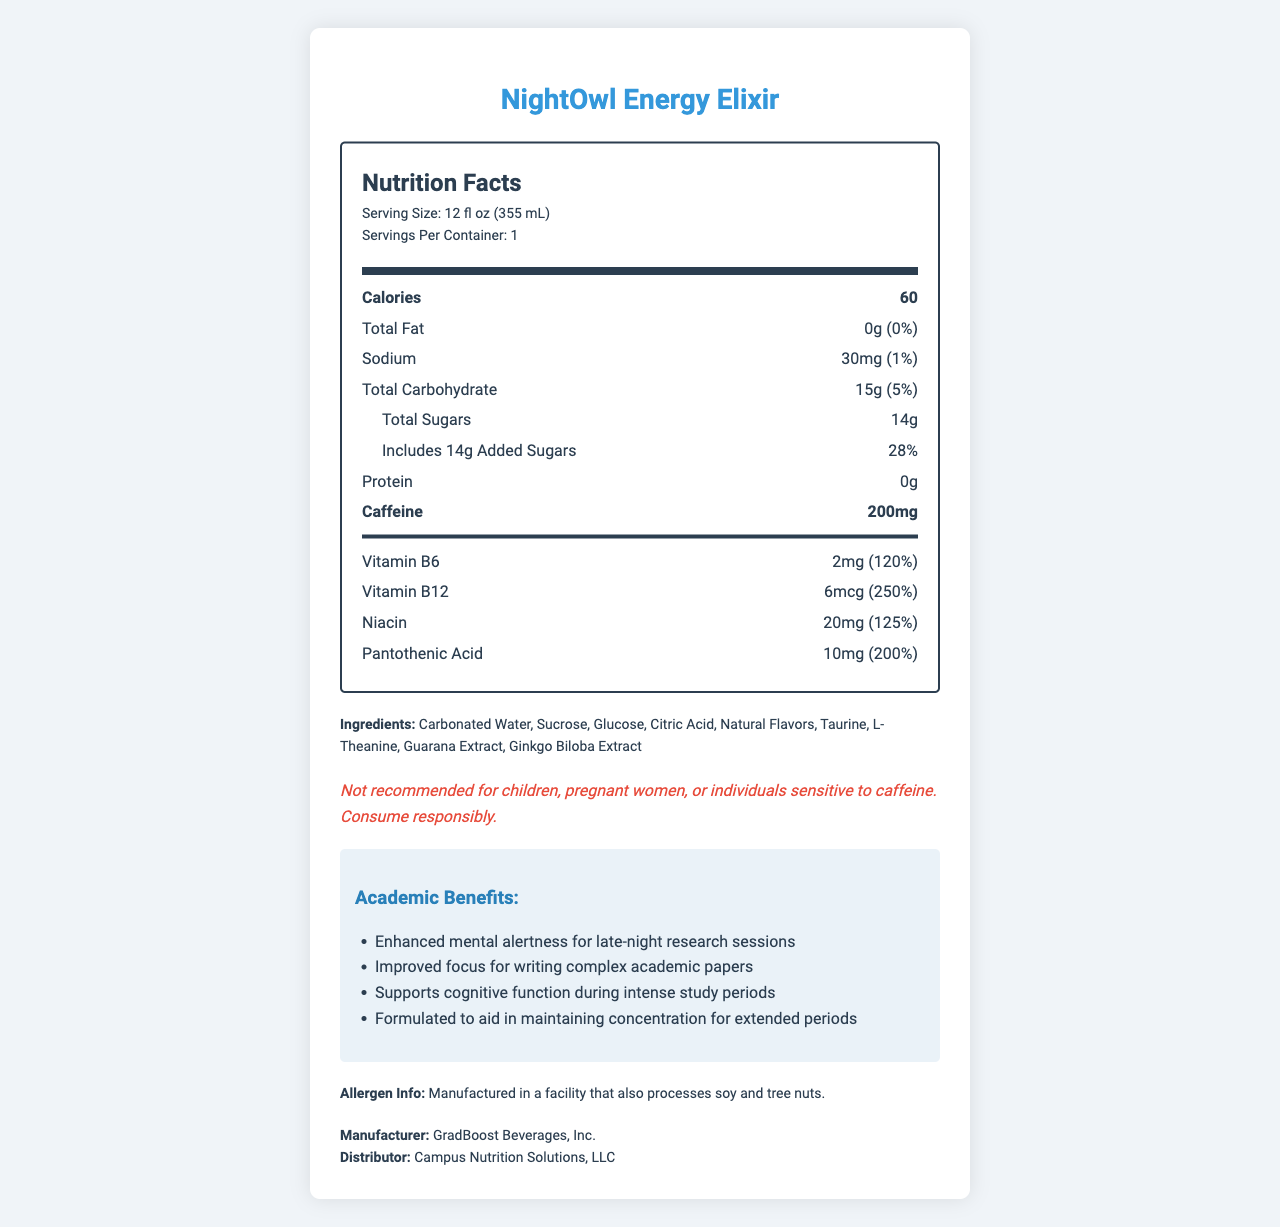what is the serving size of NightOwl Energy Elixir? The serving size is listed at the top under the 'Nutrition Facts' section, specified as 12 fl oz (355 mL).
Answer: 12 fl oz (355 mL) How many calories are there in a single serving of NightOwl Energy Elixir? The number of calories per serving is displayed prominently under the 'Nutrition Facts' section.
Answer: 60 What is the amount of caffeine in NightOwl Energy Elixir? The amount of caffeine is shown under the nutrition items and is highlighted in a bold font.
Answer: 200mg What percentage of the daily value for Vitamin B12 does NightOwl Energy Elixir provide? The daily value percentages for vitamins and minerals are listed, and Vitamin B12 provides 250% of the daily value.
Answer: 250% Name two key academic benefits of consuming NightOwl Energy Elixir. The academic benefits are listed in a bullet-point format, specifying various advantages the beverage offers for academic activities.
Answer: Enhanced mental alertness for late-night research sessions and improved focus for writing complex academic papers Which of the following is an ingredient in NightOwl Energy Elixir? A. Aspartame B. High Fructose Corn Syrup C. Taurine D. Soy Protein The ingredients list includes Taurine but not Aspartame, High Fructose Corn Syrup, or Soy Protein.
Answer: C What is the total carbohydrate content and its daily value percentage? Under the 'Nutrition Facts' section, the total carbohydrate content is listed as 15g with a 5% daily value.
Answer: 15g (5%) Is NightOwl Energy Elixir recommended for children? Yes or No The disclaimer explicitly states that the product is not recommended for children.
Answer: No Summarize the main idea of the document. The document is a comprehensive overview of NightOwl Energy Elixir, focusing on its nutritional composition and academic benefits for late-night research and writing.
Answer: The document provides detailed nutrition facts and benefits of NightOwl Energy Elixir, highlighting its use as a caffeinated beverage that supports mental alertness and focus for academic purposes. It includes nutritional information, ingredients, allergen info, and other disclaimers. What is the total added sugars content in NightOwl Energy Elixir? The total added sugars content is listed within the nutrition facts, indicating 14g of added sugars.
Answer: 14g Does the document list the manufacturer of the beverage? If so, who is it? The manufacturer is stated at the bottom of the document as GradBoost Beverages, Inc.
Answer: Yes, GradBoost Beverages, Inc. Can the document tell us if the beverage is gluten-free? The document does not specify if the beverage is gluten-free; it provides allergen information but does not mention gluten explicitly.
Answer: Not enough information 